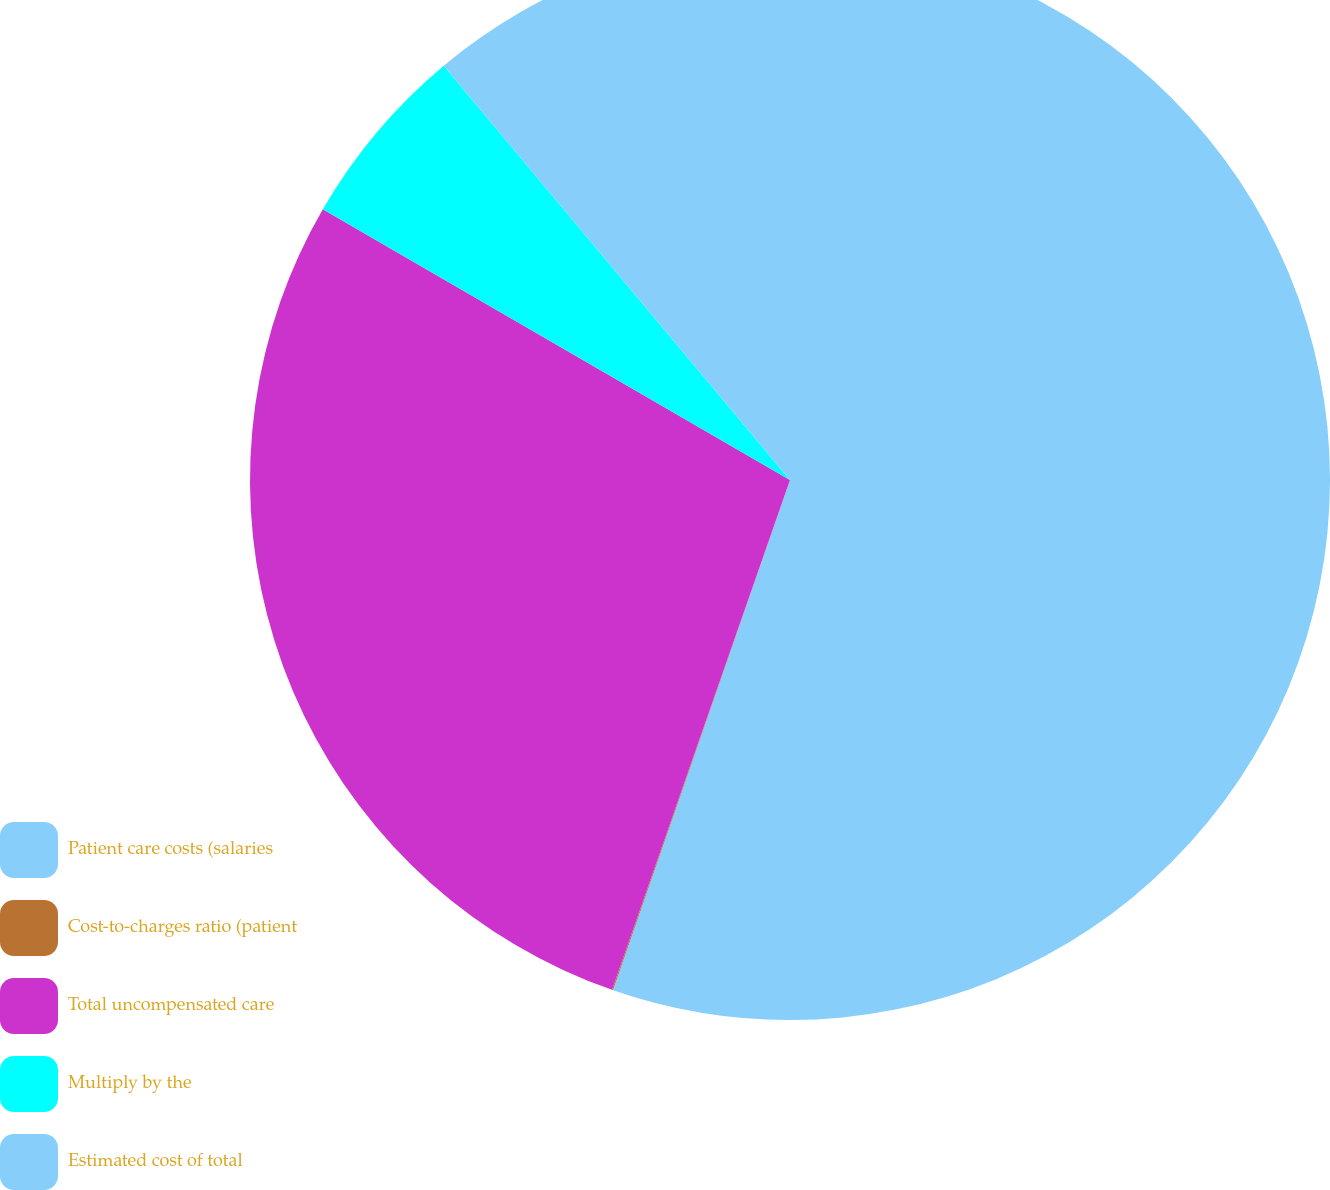<chart> <loc_0><loc_0><loc_500><loc_500><pie_chart><fcel>Patient care costs (salaries<fcel>Cost-to-charges ratio (patient<fcel>Total uncompensated care<fcel>Multiply by the<fcel>Estimated cost of total<nl><fcel>55.32%<fcel>0.03%<fcel>28.02%<fcel>5.56%<fcel>11.08%<nl></chart> 